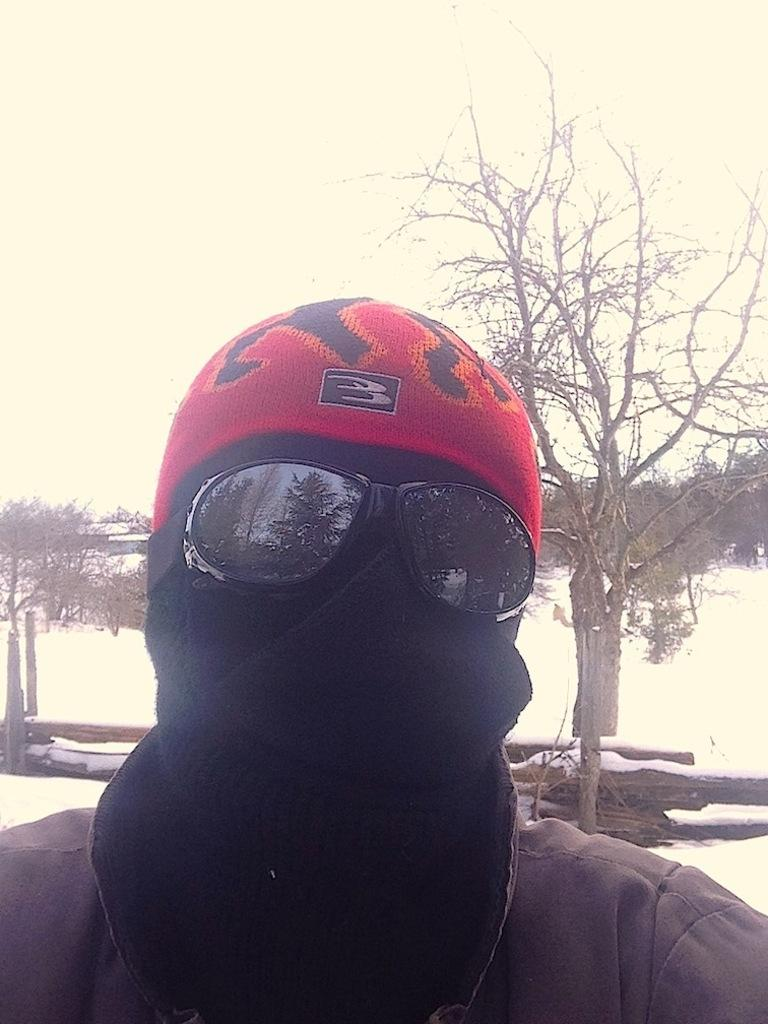Who or what is the main subject in the image? There is a person in the image. What is the person wearing? The person is wearing a brown dress. What can be seen in the background of the image? There are trees and snow visible in the background of the image. What is the color of the sky in the image? The sky is white in color. What type of meat can be seen hanging from the trees in the image? There is no meat visible in the image; the trees are in the background, and the focus is on the person and their brown dress. 